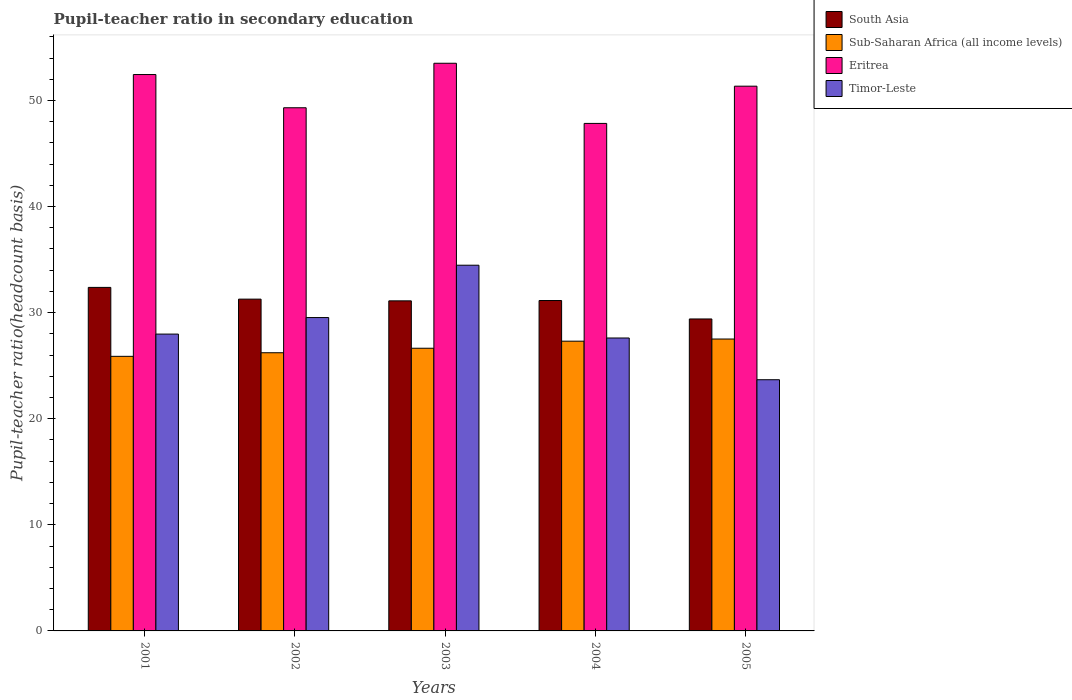How many different coloured bars are there?
Provide a short and direct response. 4. How many groups of bars are there?
Offer a very short reply. 5. Are the number of bars per tick equal to the number of legend labels?
Offer a terse response. Yes. Are the number of bars on each tick of the X-axis equal?
Make the answer very short. Yes. How many bars are there on the 5th tick from the right?
Your response must be concise. 4. In how many cases, is the number of bars for a given year not equal to the number of legend labels?
Your response must be concise. 0. What is the pupil-teacher ratio in secondary education in Timor-Leste in 2002?
Your answer should be compact. 29.54. Across all years, what is the maximum pupil-teacher ratio in secondary education in Eritrea?
Your answer should be compact. 53.51. Across all years, what is the minimum pupil-teacher ratio in secondary education in South Asia?
Provide a short and direct response. 29.41. In which year was the pupil-teacher ratio in secondary education in Eritrea minimum?
Give a very brief answer. 2004. What is the total pupil-teacher ratio in secondary education in Eritrea in the graph?
Give a very brief answer. 254.45. What is the difference between the pupil-teacher ratio in secondary education in Eritrea in 2002 and that in 2005?
Make the answer very short. -2.03. What is the difference between the pupil-teacher ratio in secondary education in Eritrea in 2003 and the pupil-teacher ratio in secondary education in Timor-Leste in 2005?
Provide a succinct answer. 29.83. What is the average pupil-teacher ratio in secondary education in Timor-Leste per year?
Your answer should be compact. 28.66. In the year 2003, what is the difference between the pupil-teacher ratio in secondary education in South Asia and pupil-teacher ratio in secondary education in Sub-Saharan Africa (all income levels)?
Give a very brief answer. 4.47. What is the ratio of the pupil-teacher ratio in secondary education in South Asia in 2001 to that in 2005?
Provide a succinct answer. 1.1. Is the difference between the pupil-teacher ratio in secondary education in South Asia in 2003 and 2005 greater than the difference between the pupil-teacher ratio in secondary education in Sub-Saharan Africa (all income levels) in 2003 and 2005?
Your answer should be very brief. Yes. What is the difference between the highest and the second highest pupil-teacher ratio in secondary education in Sub-Saharan Africa (all income levels)?
Offer a very short reply. 0.2. What is the difference between the highest and the lowest pupil-teacher ratio in secondary education in Timor-Leste?
Your answer should be very brief. 10.79. In how many years, is the pupil-teacher ratio in secondary education in Sub-Saharan Africa (all income levels) greater than the average pupil-teacher ratio in secondary education in Sub-Saharan Africa (all income levels) taken over all years?
Make the answer very short. 2. Is it the case that in every year, the sum of the pupil-teacher ratio in secondary education in Eritrea and pupil-teacher ratio in secondary education in Sub-Saharan Africa (all income levels) is greater than the sum of pupil-teacher ratio in secondary education in Timor-Leste and pupil-teacher ratio in secondary education in South Asia?
Your answer should be very brief. Yes. What does the 4th bar from the left in 2002 represents?
Provide a short and direct response. Timor-Leste. What does the 4th bar from the right in 2002 represents?
Ensure brevity in your answer.  South Asia. How many bars are there?
Your answer should be compact. 20. What is the difference between two consecutive major ticks on the Y-axis?
Offer a terse response. 10. Does the graph contain any zero values?
Your answer should be very brief. No. Does the graph contain grids?
Make the answer very short. No. How many legend labels are there?
Offer a terse response. 4. How are the legend labels stacked?
Ensure brevity in your answer.  Vertical. What is the title of the graph?
Your response must be concise. Pupil-teacher ratio in secondary education. Does "Syrian Arab Republic" appear as one of the legend labels in the graph?
Your answer should be compact. No. What is the label or title of the Y-axis?
Ensure brevity in your answer.  Pupil-teacher ratio(headcount basis). What is the Pupil-teacher ratio(headcount basis) in South Asia in 2001?
Make the answer very short. 32.38. What is the Pupil-teacher ratio(headcount basis) in Sub-Saharan Africa (all income levels) in 2001?
Ensure brevity in your answer.  25.88. What is the Pupil-teacher ratio(headcount basis) in Eritrea in 2001?
Offer a terse response. 52.44. What is the Pupil-teacher ratio(headcount basis) of Timor-Leste in 2001?
Offer a very short reply. 27.98. What is the Pupil-teacher ratio(headcount basis) of South Asia in 2002?
Give a very brief answer. 31.27. What is the Pupil-teacher ratio(headcount basis) of Sub-Saharan Africa (all income levels) in 2002?
Provide a succinct answer. 26.22. What is the Pupil-teacher ratio(headcount basis) in Eritrea in 2002?
Ensure brevity in your answer.  49.31. What is the Pupil-teacher ratio(headcount basis) in Timor-Leste in 2002?
Offer a very short reply. 29.54. What is the Pupil-teacher ratio(headcount basis) of South Asia in 2003?
Your answer should be compact. 31.11. What is the Pupil-teacher ratio(headcount basis) in Sub-Saharan Africa (all income levels) in 2003?
Ensure brevity in your answer.  26.64. What is the Pupil-teacher ratio(headcount basis) of Eritrea in 2003?
Provide a succinct answer. 53.51. What is the Pupil-teacher ratio(headcount basis) in Timor-Leste in 2003?
Provide a succinct answer. 34.47. What is the Pupil-teacher ratio(headcount basis) in South Asia in 2004?
Offer a very short reply. 31.14. What is the Pupil-teacher ratio(headcount basis) in Sub-Saharan Africa (all income levels) in 2004?
Provide a short and direct response. 27.31. What is the Pupil-teacher ratio(headcount basis) in Eritrea in 2004?
Offer a terse response. 47.84. What is the Pupil-teacher ratio(headcount basis) of Timor-Leste in 2004?
Your answer should be compact. 27.61. What is the Pupil-teacher ratio(headcount basis) in South Asia in 2005?
Provide a short and direct response. 29.41. What is the Pupil-teacher ratio(headcount basis) in Sub-Saharan Africa (all income levels) in 2005?
Keep it short and to the point. 27.51. What is the Pupil-teacher ratio(headcount basis) of Eritrea in 2005?
Make the answer very short. 51.35. What is the Pupil-teacher ratio(headcount basis) of Timor-Leste in 2005?
Offer a very short reply. 23.68. Across all years, what is the maximum Pupil-teacher ratio(headcount basis) of South Asia?
Give a very brief answer. 32.38. Across all years, what is the maximum Pupil-teacher ratio(headcount basis) in Sub-Saharan Africa (all income levels)?
Make the answer very short. 27.51. Across all years, what is the maximum Pupil-teacher ratio(headcount basis) in Eritrea?
Make the answer very short. 53.51. Across all years, what is the maximum Pupil-teacher ratio(headcount basis) of Timor-Leste?
Your answer should be very brief. 34.47. Across all years, what is the minimum Pupil-teacher ratio(headcount basis) of South Asia?
Your answer should be very brief. 29.41. Across all years, what is the minimum Pupil-teacher ratio(headcount basis) in Sub-Saharan Africa (all income levels)?
Ensure brevity in your answer.  25.88. Across all years, what is the minimum Pupil-teacher ratio(headcount basis) in Eritrea?
Give a very brief answer. 47.84. Across all years, what is the minimum Pupil-teacher ratio(headcount basis) of Timor-Leste?
Your answer should be compact. 23.68. What is the total Pupil-teacher ratio(headcount basis) in South Asia in the graph?
Offer a terse response. 155.32. What is the total Pupil-teacher ratio(headcount basis) of Sub-Saharan Africa (all income levels) in the graph?
Give a very brief answer. 133.57. What is the total Pupil-teacher ratio(headcount basis) in Eritrea in the graph?
Your answer should be very brief. 254.45. What is the total Pupil-teacher ratio(headcount basis) of Timor-Leste in the graph?
Offer a terse response. 143.28. What is the difference between the Pupil-teacher ratio(headcount basis) in South Asia in 2001 and that in 2002?
Your response must be concise. 1.11. What is the difference between the Pupil-teacher ratio(headcount basis) in Sub-Saharan Africa (all income levels) in 2001 and that in 2002?
Keep it short and to the point. -0.34. What is the difference between the Pupil-teacher ratio(headcount basis) of Eritrea in 2001 and that in 2002?
Your answer should be very brief. 3.13. What is the difference between the Pupil-teacher ratio(headcount basis) of Timor-Leste in 2001 and that in 2002?
Provide a short and direct response. -1.56. What is the difference between the Pupil-teacher ratio(headcount basis) in South Asia in 2001 and that in 2003?
Keep it short and to the point. 1.27. What is the difference between the Pupil-teacher ratio(headcount basis) of Sub-Saharan Africa (all income levels) in 2001 and that in 2003?
Keep it short and to the point. -0.76. What is the difference between the Pupil-teacher ratio(headcount basis) of Eritrea in 2001 and that in 2003?
Keep it short and to the point. -1.06. What is the difference between the Pupil-teacher ratio(headcount basis) of Timor-Leste in 2001 and that in 2003?
Provide a short and direct response. -6.49. What is the difference between the Pupil-teacher ratio(headcount basis) of South Asia in 2001 and that in 2004?
Give a very brief answer. 1.24. What is the difference between the Pupil-teacher ratio(headcount basis) in Sub-Saharan Africa (all income levels) in 2001 and that in 2004?
Your response must be concise. -1.43. What is the difference between the Pupil-teacher ratio(headcount basis) of Eritrea in 2001 and that in 2004?
Make the answer very short. 4.61. What is the difference between the Pupil-teacher ratio(headcount basis) of Timor-Leste in 2001 and that in 2004?
Offer a terse response. 0.37. What is the difference between the Pupil-teacher ratio(headcount basis) in South Asia in 2001 and that in 2005?
Keep it short and to the point. 2.97. What is the difference between the Pupil-teacher ratio(headcount basis) of Sub-Saharan Africa (all income levels) in 2001 and that in 2005?
Offer a very short reply. -1.63. What is the difference between the Pupil-teacher ratio(headcount basis) of Eritrea in 2001 and that in 2005?
Offer a terse response. 1.1. What is the difference between the Pupil-teacher ratio(headcount basis) in Timor-Leste in 2001 and that in 2005?
Ensure brevity in your answer.  4.3. What is the difference between the Pupil-teacher ratio(headcount basis) in South Asia in 2002 and that in 2003?
Offer a very short reply. 0.16. What is the difference between the Pupil-teacher ratio(headcount basis) in Sub-Saharan Africa (all income levels) in 2002 and that in 2003?
Your answer should be very brief. -0.42. What is the difference between the Pupil-teacher ratio(headcount basis) of Eritrea in 2002 and that in 2003?
Make the answer very short. -4.19. What is the difference between the Pupil-teacher ratio(headcount basis) of Timor-Leste in 2002 and that in 2003?
Make the answer very short. -4.93. What is the difference between the Pupil-teacher ratio(headcount basis) in South Asia in 2002 and that in 2004?
Offer a terse response. 0.13. What is the difference between the Pupil-teacher ratio(headcount basis) of Sub-Saharan Africa (all income levels) in 2002 and that in 2004?
Make the answer very short. -1.09. What is the difference between the Pupil-teacher ratio(headcount basis) of Eritrea in 2002 and that in 2004?
Keep it short and to the point. 1.48. What is the difference between the Pupil-teacher ratio(headcount basis) in Timor-Leste in 2002 and that in 2004?
Your answer should be compact. 1.93. What is the difference between the Pupil-teacher ratio(headcount basis) in South Asia in 2002 and that in 2005?
Provide a succinct answer. 1.87. What is the difference between the Pupil-teacher ratio(headcount basis) in Sub-Saharan Africa (all income levels) in 2002 and that in 2005?
Give a very brief answer. -1.29. What is the difference between the Pupil-teacher ratio(headcount basis) of Eritrea in 2002 and that in 2005?
Offer a very short reply. -2.03. What is the difference between the Pupil-teacher ratio(headcount basis) in Timor-Leste in 2002 and that in 2005?
Give a very brief answer. 5.86. What is the difference between the Pupil-teacher ratio(headcount basis) of South Asia in 2003 and that in 2004?
Make the answer very short. -0.03. What is the difference between the Pupil-teacher ratio(headcount basis) of Sub-Saharan Africa (all income levels) in 2003 and that in 2004?
Give a very brief answer. -0.67. What is the difference between the Pupil-teacher ratio(headcount basis) in Eritrea in 2003 and that in 2004?
Ensure brevity in your answer.  5.67. What is the difference between the Pupil-teacher ratio(headcount basis) in Timor-Leste in 2003 and that in 2004?
Your response must be concise. 6.86. What is the difference between the Pupil-teacher ratio(headcount basis) of South Asia in 2003 and that in 2005?
Provide a succinct answer. 1.71. What is the difference between the Pupil-teacher ratio(headcount basis) in Sub-Saharan Africa (all income levels) in 2003 and that in 2005?
Ensure brevity in your answer.  -0.87. What is the difference between the Pupil-teacher ratio(headcount basis) of Eritrea in 2003 and that in 2005?
Offer a very short reply. 2.16. What is the difference between the Pupil-teacher ratio(headcount basis) of Timor-Leste in 2003 and that in 2005?
Offer a very short reply. 10.79. What is the difference between the Pupil-teacher ratio(headcount basis) in South Asia in 2004 and that in 2005?
Provide a short and direct response. 1.74. What is the difference between the Pupil-teacher ratio(headcount basis) in Sub-Saharan Africa (all income levels) in 2004 and that in 2005?
Provide a succinct answer. -0.2. What is the difference between the Pupil-teacher ratio(headcount basis) of Eritrea in 2004 and that in 2005?
Give a very brief answer. -3.51. What is the difference between the Pupil-teacher ratio(headcount basis) in Timor-Leste in 2004 and that in 2005?
Provide a succinct answer. 3.93. What is the difference between the Pupil-teacher ratio(headcount basis) of South Asia in 2001 and the Pupil-teacher ratio(headcount basis) of Sub-Saharan Africa (all income levels) in 2002?
Provide a succinct answer. 6.16. What is the difference between the Pupil-teacher ratio(headcount basis) in South Asia in 2001 and the Pupil-teacher ratio(headcount basis) in Eritrea in 2002?
Your answer should be very brief. -16.93. What is the difference between the Pupil-teacher ratio(headcount basis) of South Asia in 2001 and the Pupil-teacher ratio(headcount basis) of Timor-Leste in 2002?
Keep it short and to the point. 2.84. What is the difference between the Pupil-teacher ratio(headcount basis) in Sub-Saharan Africa (all income levels) in 2001 and the Pupil-teacher ratio(headcount basis) in Eritrea in 2002?
Make the answer very short. -23.43. What is the difference between the Pupil-teacher ratio(headcount basis) of Sub-Saharan Africa (all income levels) in 2001 and the Pupil-teacher ratio(headcount basis) of Timor-Leste in 2002?
Provide a succinct answer. -3.66. What is the difference between the Pupil-teacher ratio(headcount basis) of Eritrea in 2001 and the Pupil-teacher ratio(headcount basis) of Timor-Leste in 2002?
Offer a very short reply. 22.91. What is the difference between the Pupil-teacher ratio(headcount basis) in South Asia in 2001 and the Pupil-teacher ratio(headcount basis) in Sub-Saharan Africa (all income levels) in 2003?
Give a very brief answer. 5.74. What is the difference between the Pupil-teacher ratio(headcount basis) in South Asia in 2001 and the Pupil-teacher ratio(headcount basis) in Eritrea in 2003?
Your answer should be very brief. -21.13. What is the difference between the Pupil-teacher ratio(headcount basis) in South Asia in 2001 and the Pupil-teacher ratio(headcount basis) in Timor-Leste in 2003?
Offer a very short reply. -2.09. What is the difference between the Pupil-teacher ratio(headcount basis) of Sub-Saharan Africa (all income levels) in 2001 and the Pupil-teacher ratio(headcount basis) of Eritrea in 2003?
Ensure brevity in your answer.  -27.63. What is the difference between the Pupil-teacher ratio(headcount basis) of Sub-Saharan Africa (all income levels) in 2001 and the Pupil-teacher ratio(headcount basis) of Timor-Leste in 2003?
Your answer should be compact. -8.59. What is the difference between the Pupil-teacher ratio(headcount basis) of Eritrea in 2001 and the Pupil-teacher ratio(headcount basis) of Timor-Leste in 2003?
Your answer should be very brief. 17.97. What is the difference between the Pupil-teacher ratio(headcount basis) of South Asia in 2001 and the Pupil-teacher ratio(headcount basis) of Sub-Saharan Africa (all income levels) in 2004?
Your answer should be compact. 5.07. What is the difference between the Pupil-teacher ratio(headcount basis) in South Asia in 2001 and the Pupil-teacher ratio(headcount basis) in Eritrea in 2004?
Offer a very short reply. -15.46. What is the difference between the Pupil-teacher ratio(headcount basis) of South Asia in 2001 and the Pupil-teacher ratio(headcount basis) of Timor-Leste in 2004?
Your answer should be compact. 4.77. What is the difference between the Pupil-teacher ratio(headcount basis) of Sub-Saharan Africa (all income levels) in 2001 and the Pupil-teacher ratio(headcount basis) of Eritrea in 2004?
Offer a very short reply. -21.95. What is the difference between the Pupil-teacher ratio(headcount basis) of Sub-Saharan Africa (all income levels) in 2001 and the Pupil-teacher ratio(headcount basis) of Timor-Leste in 2004?
Your answer should be compact. -1.73. What is the difference between the Pupil-teacher ratio(headcount basis) in Eritrea in 2001 and the Pupil-teacher ratio(headcount basis) in Timor-Leste in 2004?
Give a very brief answer. 24.83. What is the difference between the Pupil-teacher ratio(headcount basis) of South Asia in 2001 and the Pupil-teacher ratio(headcount basis) of Sub-Saharan Africa (all income levels) in 2005?
Offer a terse response. 4.87. What is the difference between the Pupil-teacher ratio(headcount basis) of South Asia in 2001 and the Pupil-teacher ratio(headcount basis) of Eritrea in 2005?
Your answer should be very brief. -18.97. What is the difference between the Pupil-teacher ratio(headcount basis) in South Asia in 2001 and the Pupil-teacher ratio(headcount basis) in Timor-Leste in 2005?
Provide a short and direct response. 8.7. What is the difference between the Pupil-teacher ratio(headcount basis) in Sub-Saharan Africa (all income levels) in 2001 and the Pupil-teacher ratio(headcount basis) in Eritrea in 2005?
Make the answer very short. -25.46. What is the difference between the Pupil-teacher ratio(headcount basis) of Sub-Saharan Africa (all income levels) in 2001 and the Pupil-teacher ratio(headcount basis) of Timor-Leste in 2005?
Ensure brevity in your answer.  2.2. What is the difference between the Pupil-teacher ratio(headcount basis) in Eritrea in 2001 and the Pupil-teacher ratio(headcount basis) in Timor-Leste in 2005?
Provide a succinct answer. 28.77. What is the difference between the Pupil-teacher ratio(headcount basis) of South Asia in 2002 and the Pupil-teacher ratio(headcount basis) of Sub-Saharan Africa (all income levels) in 2003?
Make the answer very short. 4.63. What is the difference between the Pupil-teacher ratio(headcount basis) of South Asia in 2002 and the Pupil-teacher ratio(headcount basis) of Eritrea in 2003?
Ensure brevity in your answer.  -22.23. What is the difference between the Pupil-teacher ratio(headcount basis) in South Asia in 2002 and the Pupil-teacher ratio(headcount basis) in Timor-Leste in 2003?
Give a very brief answer. -3.2. What is the difference between the Pupil-teacher ratio(headcount basis) in Sub-Saharan Africa (all income levels) in 2002 and the Pupil-teacher ratio(headcount basis) in Eritrea in 2003?
Provide a succinct answer. -27.29. What is the difference between the Pupil-teacher ratio(headcount basis) in Sub-Saharan Africa (all income levels) in 2002 and the Pupil-teacher ratio(headcount basis) in Timor-Leste in 2003?
Offer a very short reply. -8.25. What is the difference between the Pupil-teacher ratio(headcount basis) of Eritrea in 2002 and the Pupil-teacher ratio(headcount basis) of Timor-Leste in 2003?
Provide a short and direct response. 14.84. What is the difference between the Pupil-teacher ratio(headcount basis) of South Asia in 2002 and the Pupil-teacher ratio(headcount basis) of Sub-Saharan Africa (all income levels) in 2004?
Your answer should be very brief. 3.96. What is the difference between the Pupil-teacher ratio(headcount basis) of South Asia in 2002 and the Pupil-teacher ratio(headcount basis) of Eritrea in 2004?
Offer a very short reply. -16.56. What is the difference between the Pupil-teacher ratio(headcount basis) of South Asia in 2002 and the Pupil-teacher ratio(headcount basis) of Timor-Leste in 2004?
Offer a very short reply. 3.66. What is the difference between the Pupil-teacher ratio(headcount basis) in Sub-Saharan Africa (all income levels) in 2002 and the Pupil-teacher ratio(headcount basis) in Eritrea in 2004?
Ensure brevity in your answer.  -21.62. What is the difference between the Pupil-teacher ratio(headcount basis) in Sub-Saharan Africa (all income levels) in 2002 and the Pupil-teacher ratio(headcount basis) in Timor-Leste in 2004?
Ensure brevity in your answer.  -1.39. What is the difference between the Pupil-teacher ratio(headcount basis) of Eritrea in 2002 and the Pupil-teacher ratio(headcount basis) of Timor-Leste in 2004?
Provide a succinct answer. 21.7. What is the difference between the Pupil-teacher ratio(headcount basis) in South Asia in 2002 and the Pupil-teacher ratio(headcount basis) in Sub-Saharan Africa (all income levels) in 2005?
Offer a terse response. 3.76. What is the difference between the Pupil-teacher ratio(headcount basis) of South Asia in 2002 and the Pupil-teacher ratio(headcount basis) of Eritrea in 2005?
Offer a very short reply. -20.07. What is the difference between the Pupil-teacher ratio(headcount basis) in South Asia in 2002 and the Pupil-teacher ratio(headcount basis) in Timor-Leste in 2005?
Make the answer very short. 7.6. What is the difference between the Pupil-teacher ratio(headcount basis) in Sub-Saharan Africa (all income levels) in 2002 and the Pupil-teacher ratio(headcount basis) in Eritrea in 2005?
Keep it short and to the point. -25.13. What is the difference between the Pupil-teacher ratio(headcount basis) of Sub-Saharan Africa (all income levels) in 2002 and the Pupil-teacher ratio(headcount basis) of Timor-Leste in 2005?
Ensure brevity in your answer.  2.54. What is the difference between the Pupil-teacher ratio(headcount basis) in Eritrea in 2002 and the Pupil-teacher ratio(headcount basis) in Timor-Leste in 2005?
Provide a succinct answer. 25.64. What is the difference between the Pupil-teacher ratio(headcount basis) of South Asia in 2003 and the Pupil-teacher ratio(headcount basis) of Sub-Saharan Africa (all income levels) in 2004?
Your response must be concise. 3.8. What is the difference between the Pupil-teacher ratio(headcount basis) of South Asia in 2003 and the Pupil-teacher ratio(headcount basis) of Eritrea in 2004?
Ensure brevity in your answer.  -16.73. What is the difference between the Pupil-teacher ratio(headcount basis) in South Asia in 2003 and the Pupil-teacher ratio(headcount basis) in Timor-Leste in 2004?
Give a very brief answer. 3.5. What is the difference between the Pupil-teacher ratio(headcount basis) of Sub-Saharan Africa (all income levels) in 2003 and the Pupil-teacher ratio(headcount basis) of Eritrea in 2004?
Provide a succinct answer. -21.19. What is the difference between the Pupil-teacher ratio(headcount basis) of Sub-Saharan Africa (all income levels) in 2003 and the Pupil-teacher ratio(headcount basis) of Timor-Leste in 2004?
Make the answer very short. -0.97. What is the difference between the Pupil-teacher ratio(headcount basis) of Eritrea in 2003 and the Pupil-teacher ratio(headcount basis) of Timor-Leste in 2004?
Keep it short and to the point. 25.9. What is the difference between the Pupil-teacher ratio(headcount basis) in South Asia in 2003 and the Pupil-teacher ratio(headcount basis) in Sub-Saharan Africa (all income levels) in 2005?
Your response must be concise. 3.6. What is the difference between the Pupil-teacher ratio(headcount basis) in South Asia in 2003 and the Pupil-teacher ratio(headcount basis) in Eritrea in 2005?
Provide a short and direct response. -20.24. What is the difference between the Pupil-teacher ratio(headcount basis) of South Asia in 2003 and the Pupil-teacher ratio(headcount basis) of Timor-Leste in 2005?
Keep it short and to the point. 7.43. What is the difference between the Pupil-teacher ratio(headcount basis) in Sub-Saharan Africa (all income levels) in 2003 and the Pupil-teacher ratio(headcount basis) in Eritrea in 2005?
Provide a succinct answer. -24.7. What is the difference between the Pupil-teacher ratio(headcount basis) of Sub-Saharan Africa (all income levels) in 2003 and the Pupil-teacher ratio(headcount basis) of Timor-Leste in 2005?
Offer a very short reply. 2.97. What is the difference between the Pupil-teacher ratio(headcount basis) in Eritrea in 2003 and the Pupil-teacher ratio(headcount basis) in Timor-Leste in 2005?
Your answer should be compact. 29.83. What is the difference between the Pupil-teacher ratio(headcount basis) of South Asia in 2004 and the Pupil-teacher ratio(headcount basis) of Sub-Saharan Africa (all income levels) in 2005?
Keep it short and to the point. 3.63. What is the difference between the Pupil-teacher ratio(headcount basis) of South Asia in 2004 and the Pupil-teacher ratio(headcount basis) of Eritrea in 2005?
Your response must be concise. -20.2. What is the difference between the Pupil-teacher ratio(headcount basis) of South Asia in 2004 and the Pupil-teacher ratio(headcount basis) of Timor-Leste in 2005?
Ensure brevity in your answer.  7.47. What is the difference between the Pupil-teacher ratio(headcount basis) of Sub-Saharan Africa (all income levels) in 2004 and the Pupil-teacher ratio(headcount basis) of Eritrea in 2005?
Your answer should be compact. -24.04. What is the difference between the Pupil-teacher ratio(headcount basis) of Sub-Saharan Africa (all income levels) in 2004 and the Pupil-teacher ratio(headcount basis) of Timor-Leste in 2005?
Give a very brief answer. 3.63. What is the difference between the Pupil-teacher ratio(headcount basis) of Eritrea in 2004 and the Pupil-teacher ratio(headcount basis) of Timor-Leste in 2005?
Give a very brief answer. 24.16. What is the average Pupil-teacher ratio(headcount basis) in South Asia per year?
Offer a terse response. 31.06. What is the average Pupil-teacher ratio(headcount basis) of Sub-Saharan Africa (all income levels) per year?
Your response must be concise. 26.71. What is the average Pupil-teacher ratio(headcount basis) in Eritrea per year?
Give a very brief answer. 50.89. What is the average Pupil-teacher ratio(headcount basis) in Timor-Leste per year?
Provide a short and direct response. 28.66. In the year 2001, what is the difference between the Pupil-teacher ratio(headcount basis) of South Asia and Pupil-teacher ratio(headcount basis) of Sub-Saharan Africa (all income levels)?
Keep it short and to the point. 6.5. In the year 2001, what is the difference between the Pupil-teacher ratio(headcount basis) of South Asia and Pupil-teacher ratio(headcount basis) of Eritrea?
Your answer should be very brief. -20.06. In the year 2001, what is the difference between the Pupil-teacher ratio(headcount basis) in South Asia and Pupil-teacher ratio(headcount basis) in Timor-Leste?
Keep it short and to the point. 4.4. In the year 2001, what is the difference between the Pupil-teacher ratio(headcount basis) in Sub-Saharan Africa (all income levels) and Pupil-teacher ratio(headcount basis) in Eritrea?
Offer a terse response. -26.56. In the year 2001, what is the difference between the Pupil-teacher ratio(headcount basis) in Sub-Saharan Africa (all income levels) and Pupil-teacher ratio(headcount basis) in Timor-Leste?
Offer a very short reply. -2.1. In the year 2001, what is the difference between the Pupil-teacher ratio(headcount basis) in Eritrea and Pupil-teacher ratio(headcount basis) in Timor-Leste?
Ensure brevity in your answer.  24.46. In the year 2002, what is the difference between the Pupil-teacher ratio(headcount basis) in South Asia and Pupil-teacher ratio(headcount basis) in Sub-Saharan Africa (all income levels)?
Give a very brief answer. 5.05. In the year 2002, what is the difference between the Pupil-teacher ratio(headcount basis) of South Asia and Pupil-teacher ratio(headcount basis) of Eritrea?
Your answer should be very brief. -18.04. In the year 2002, what is the difference between the Pupil-teacher ratio(headcount basis) of South Asia and Pupil-teacher ratio(headcount basis) of Timor-Leste?
Provide a short and direct response. 1.74. In the year 2002, what is the difference between the Pupil-teacher ratio(headcount basis) of Sub-Saharan Africa (all income levels) and Pupil-teacher ratio(headcount basis) of Eritrea?
Offer a terse response. -23.09. In the year 2002, what is the difference between the Pupil-teacher ratio(headcount basis) of Sub-Saharan Africa (all income levels) and Pupil-teacher ratio(headcount basis) of Timor-Leste?
Offer a very short reply. -3.32. In the year 2002, what is the difference between the Pupil-teacher ratio(headcount basis) in Eritrea and Pupil-teacher ratio(headcount basis) in Timor-Leste?
Provide a succinct answer. 19.77. In the year 2003, what is the difference between the Pupil-teacher ratio(headcount basis) of South Asia and Pupil-teacher ratio(headcount basis) of Sub-Saharan Africa (all income levels)?
Offer a very short reply. 4.47. In the year 2003, what is the difference between the Pupil-teacher ratio(headcount basis) of South Asia and Pupil-teacher ratio(headcount basis) of Eritrea?
Your response must be concise. -22.4. In the year 2003, what is the difference between the Pupil-teacher ratio(headcount basis) in South Asia and Pupil-teacher ratio(headcount basis) in Timor-Leste?
Provide a short and direct response. -3.36. In the year 2003, what is the difference between the Pupil-teacher ratio(headcount basis) in Sub-Saharan Africa (all income levels) and Pupil-teacher ratio(headcount basis) in Eritrea?
Give a very brief answer. -26.86. In the year 2003, what is the difference between the Pupil-teacher ratio(headcount basis) in Sub-Saharan Africa (all income levels) and Pupil-teacher ratio(headcount basis) in Timor-Leste?
Provide a succinct answer. -7.83. In the year 2003, what is the difference between the Pupil-teacher ratio(headcount basis) in Eritrea and Pupil-teacher ratio(headcount basis) in Timor-Leste?
Offer a terse response. 19.04. In the year 2004, what is the difference between the Pupil-teacher ratio(headcount basis) of South Asia and Pupil-teacher ratio(headcount basis) of Sub-Saharan Africa (all income levels)?
Make the answer very short. 3.83. In the year 2004, what is the difference between the Pupil-teacher ratio(headcount basis) of South Asia and Pupil-teacher ratio(headcount basis) of Eritrea?
Keep it short and to the point. -16.69. In the year 2004, what is the difference between the Pupil-teacher ratio(headcount basis) of South Asia and Pupil-teacher ratio(headcount basis) of Timor-Leste?
Provide a short and direct response. 3.53. In the year 2004, what is the difference between the Pupil-teacher ratio(headcount basis) in Sub-Saharan Africa (all income levels) and Pupil-teacher ratio(headcount basis) in Eritrea?
Keep it short and to the point. -20.53. In the year 2004, what is the difference between the Pupil-teacher ratio(headcount basis) in Sub-Saharan Africa (all income levels) and Pupil-teacher ratio(headcount basis) in Timor-Leste?
Your answer should be very brief. -0.3. In the year 2004, what is the difference between the Pupil-teacher ratio(headcount basis) of Eritrea and Pupil-teacher ratio(headcount basis) of Timor-Leste?
Make the answer very short. 20.23. In the year 2005, what is the difference between the Pupil-teacher ratio(headcount basis) of South Asia and Pupil-teacher ratio(headcount basis) of Sub-Saharan Africa (all income levels)?
Make the answer very short. 1.89. In the year 2005, what is the difference between the Pupil-teacher ratio(headcount basis) in South Asia and Pupil-teacher ratio(headcount basis) in Eritrea?
Keep it short and to the point. -21.94. In the year 2005, what is the difference between the Pupil-teacher ratio(headcount basis) of South Asia and Pupil-teacher ratio(headcount basis) of Timor-Leste?
Ensure brevity in your answer.  5.73. In the year 2005, what is the difference between the Pupil-teacher ratio(headcount basis) in Sub-Saharan Africa (all income levels) and Pupil-teacher ratio(headcount basis) in Eritrea?
Offer a terse response. -23.83. In the year 2005, what is the difference between the Pupil-teacher ratio(headcount basis) of Sub-Saharan Africa (all income levels) and Pupil-teacher ratio(headcount basis) of Timor-Leste?
Your answer should be compact. 3.84. In the year 2005, what is the difference between the Pupil-teacher ratio(headcount basis) in Eritrea and Pupil-teacher ratio(headcount basis) in Timor-Leste?
Provide a succinct answer. 27.67. What is the ratio of the Pupil-teacher ratio(headcount basis) in South Asia in 2001 to that in 2002?
Your answer should be very brief. 1.04. What is the ratio of the Pupil-teacher ratio(headcount basis) of Sub-Saharan Africa (all income levels) in 2001 to that in 2002?
Your response must be concise. 0.99. What is the ratio of the Pupil-teacher ratio(headcount basis) in Eritrea in 2001 to that in 2002?
Provide a succinct answer. 1.06. What is the ratio of the Pupil-teacher ratio(headcount basis) of Timor-Leste in 2001 to that in 2002?
Make the answer very short. 0.95. What is the ratio of the Pupil-teacher ratio(headcount basis) in South Asia in 2001 to that in 2003?
Give a very brief answer. 1.04. What is the ratio of the Pupil-teacher ratio(headcount basis) in Sub-Saharan Africa (all income levels) in 2001 to that in 2003?
Provide a succinct answer. 0.97. What is the ratio of the Pupil-teacher ratio(headcount basis) of Eritrea in 2001 to that in 2003?
Keep it short and to the point. 0.98. What is the ratio of the Pupil-teacher ratio(headcount basis) of Timor-Leste in 2001 to that in 2003?
Provide a short and direct response. 0.81. What is the ratio of the Pupil-teacher ratio(headcount basis) of South Asia in 2001 to that in 2004?
Offer a very short reply. 1.04. What is the ratio of the Pupil-teacher ratio(headcount basis) of Sub-Saharan Africa (all income levels) in 2001 to that in 2004?
Offer a terse response. 0.95. What is the ratio of the Pupil-teacher ratio(headcount basis) in Eritrea in 2001 to that in 2004?
Your answer should be compact. 1.1. What is the ratio of the Pupil-teacher ratio(headcount basis) in Timor-Leste in 2001 to that in 2004?
Your response must be concise. 1.01. What is the ratio of the Pupil-teacher ratio(headcount basis) of South Asia in 2001 to that in 2005?
Ensure brevity in your answer.  1.1. What is the ratio of the Pupil-teacher ratio(headcount basis) in Sub-Saharan Africa (all income levels) in 2001 to that in 2005?
Give a very brief answer. 0.94. What is the ratio of the Pupil-teacher ratio(headcount basis) of Eritrea in 2001 to that in 2005?
Offer a very short reply. 1.02. What is the ratio of the Pupil-teacher ratio(headcount basis) in Timor-Leste in 2001 to that in 2005?
Your response must be concise. 1.18. What is the ratio of the Pupil-teacher ratio(headcount basis) of Sub-Saharan Africa (all income levels) in 2002 to that in 2003?
Give a very brief answer. 0.98. What is the ratio of the Pupil-teacher ratio(headcount basis) in Eritrea in 2002 to that in 2003?
Provide a short and direct response. 0.92. What is the ratio of the Pupil-teacher ratio(headcount basis) in Timor-Leste in 2002 to that in 2003?
Offer a very short reply. 0.86. What is the ratio of the Pupil-teacher ratio(headcount basis) of South Asia in 2002 to that in 2004?
Your response must be concise. 1. What is the ratio of the Pupil-teacher ratio(headcount basis) in Sub-Saharan Africa (all income levels) in 2002 to that in 2004?
Offer a very short reply. 0.96. What is the ratio of the Pupil-teacher ratio(headcount basis) in Eritrea in 2002 to that in 2004?
Your answer should be compact. 1.03. What is the ratio of the Pupil-teacher ratio(headcount basis) in Timor-Leste in 2002 to that in 2004?
Give a very brief answer. 1.07. What is the ratio of the Pupil-teacher ratio(headcount basis) of South Asia in 2002 to that in 2005?
Make the answer very short. 1.06. What is the ratio of the Pupil-teacher ratio(headcount basis) of Sub-Saharan Africa (all income levels) in 2002 to that in 2005?
Your answer should be compact. 0.95. What is the ratio of the Pupil-teacher ratio(headcount basis) in Eritrea in 2002 to that in 2005?
Your response must be concise. 0.96. What is the ratio of the Pupil-teacher ratio(headcount basis) in Timor-Leste in 2002 to that in 2005?
Give a very brief answer. 1.25. What is the ratio of the Pupil-teacher ratio(headcount basis) in South Asia in 2003 to that in 2004?
Provide a short and direct response. 1. What is the ratio of the Pupil-teacher ratio(headcount basis) in Sub-Saharan Africa (all income levels) in 2003 to that in 2004?
Your answer should be compact. 0.98. What is the ratio of the Pupil-teacher ratio(headcount basis) of Eritrea in 2003 to that in 2004?
Make the answer very short. 1.12. What is the ratio of the Pupil-teacher ratio(headcount basis) in Timor-Leste in 2003 to that in 2004?
Offer a terse response. 1.25. What is the ratio of the Pupil-teacher ratio(headcount basis) in South Asia in 2003 to that in 2005?
Provide a short and direct response. 1.06. What is the ratio of the Pupil-teacher ratio(headcount basis) in Sub-Saharan Africa (all income levels) in 2003 to that in 2005?
Your answer should be compact. 0.97. What is the ratio of the Pupil-teacher ratio(headcount basis) of Eritrea in 2003 to that in 2005?
Your answer should be very brief. 1.04. What is the ratio of the Pupil-teacher ratio(headcount basis) in Timor-Leste in 2003 to that in 2005?
Ensure brevity in your answer.  1.46. What is the ratio of the Pupil-teacher ratio(headcount basis) of South Asia in 2004 to that in 2005?
Offer a very short reply. 1.06. What is the ratio of the Pupil-teacher ratio(headcount basis) of Sub-Saharan Africa (all income levels) in 2004 to that in 2005?
Provide a short and direct response. 0.99. What is the ratio of the Pupil-teacher ratio(headcount basis) of Eritrea in 2004 to that in 2005?
Your response must be concise. 0.93. What is the ratio of the Pupil-teacher ratio(headcount basis) of Timor-Leste in 2004 to that in 2005?
Offer a terse response. 1.17. What is the difference between the highest and the second highest Pupil-teacher ratio(headcount basis) of South Asia?
Make the answer very short. 1.11. What is the difference between the highest and the second highest Pupil-teacher ratio(headcount basis) of Sub-Saharan Africa (all income levels)?
Provide a short and direct response. 0.2. What is the difference between the highest and the second highest Pupil-teacher ratio(headcount basis) of Eritrea?
Your answer should be compact. 1.06. What is the difference between the highest and the second highest Pupil-teacher ratio(headcount basis) of Timor-Leste?
Provide a short and direct response. 4.93. What is the difference between the highest and the lowest Pupil-teacher ratio(headcount basis) of South Asia?
Give a very brief answer. 2.97. What is the difference between the highest and the lowest Pupil-teacher ratio(headcount basis) in Sub-Saharan Africa (all income levels)?
Make the answer very short. 1.63. What is the difference between the highest and the lowest Pupil-teacher ratio(headcount basis) in Eritrea?
Provide a short and direct response. 5.67. What is the difference between the highest and the lowest Pupil-teacher ratio(headcount basis) in Timor-Leste?
Offer a terse response. 10.79. 